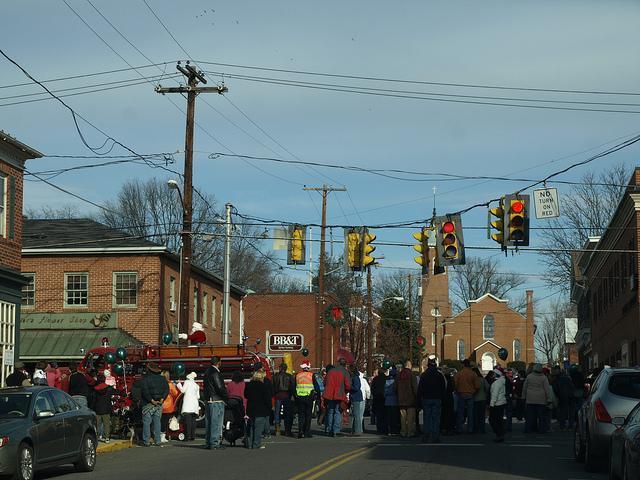How many lantern's are red?
Give a very brief answer. 2. How many people are wearing safety jackets?
Give a very brief answer. 1. How many cars are there?
Give a very brief answer. 3. How many big orange are there in the image ?
Give a very brief answer. 0. 